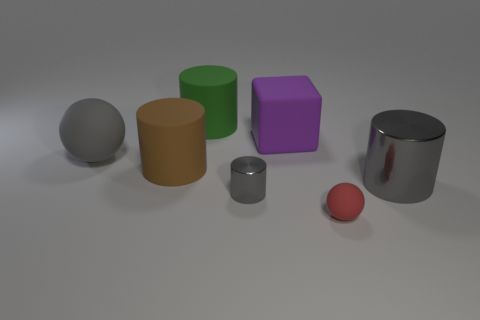Subtract all purple blocks. How many gray cylinders are left? 2 Add 1 yellow matte objects. How many objects exist? 8 Subtract all brown matte cylinders. How many cylinders are left? 3 Subtract all green cylinders. How many cylinders are left? 3 Subtract all cubes. How many objects are left? 6 Add 4 matte cylinders. How many matte cylinders are left? 6 Add 4 small red cylinders. How many small red cylinders exist? 4 Subtract 0 purple cylinders. How many objects are left? 7 Subtract all brown cylinders. Subtract all brown balls. How many cylinders are left? 3 Subtract all large yellow blocks. Subtract all large gray matte things. How many objects are left? 6 